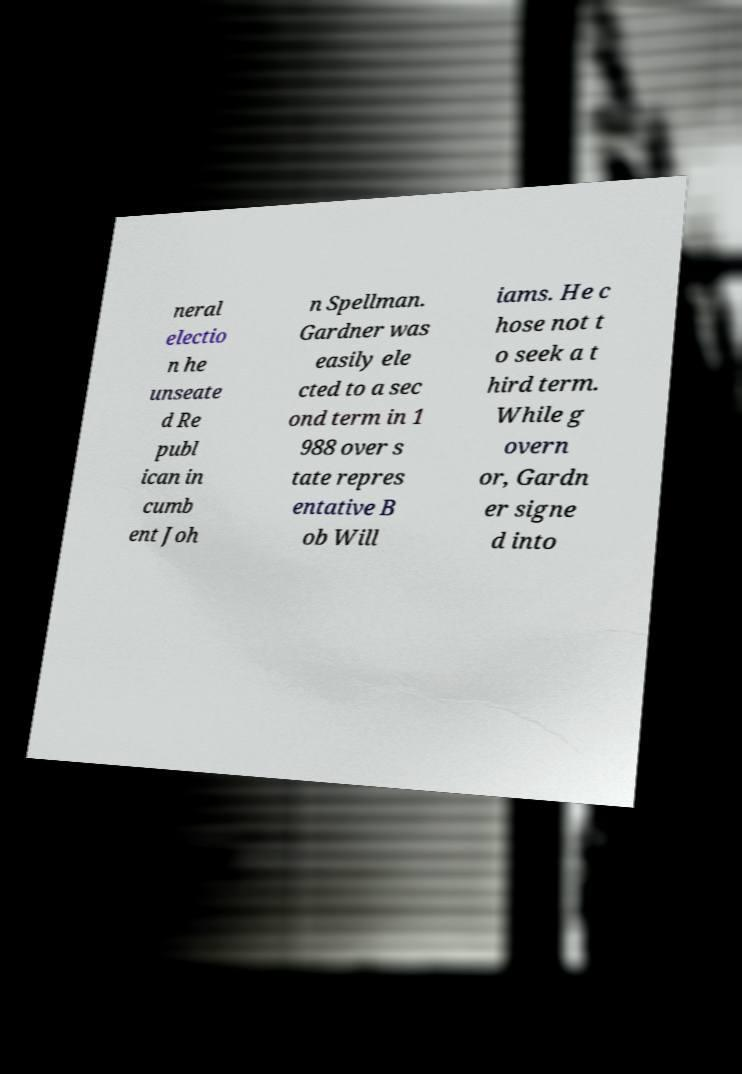Please read and relay the text visible in this image. What does it say? neral electio n he unseate d Re publ ican in cumb ent Joh n Spellman. Gardner was easily ele cted to a sec ond term in 1 988 over s tate repres entative B ob Will iams. He c hose not t o seek a t hird term. While g overn or, Gardn er signe d into 